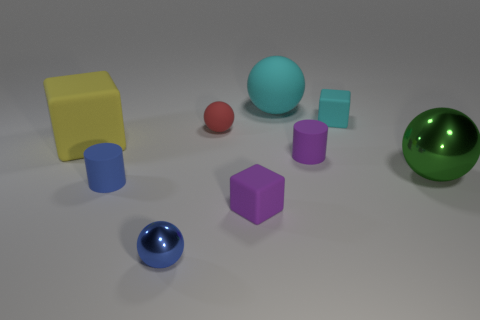Add 1 small cyan balls. How many objects exist? 10 Subtract all cylinders. How many objects are left? 7 Add 5 big green spheres. How many big green spheres exist? 6 Subtract 1 cyan balls. How many objects are left? 8 Subtract all blue metallic things. Subtract all cylinders. How many objects are left? 6 Add 4 tiny purple cylinders. How many tiny purple cylinders are left? 5 